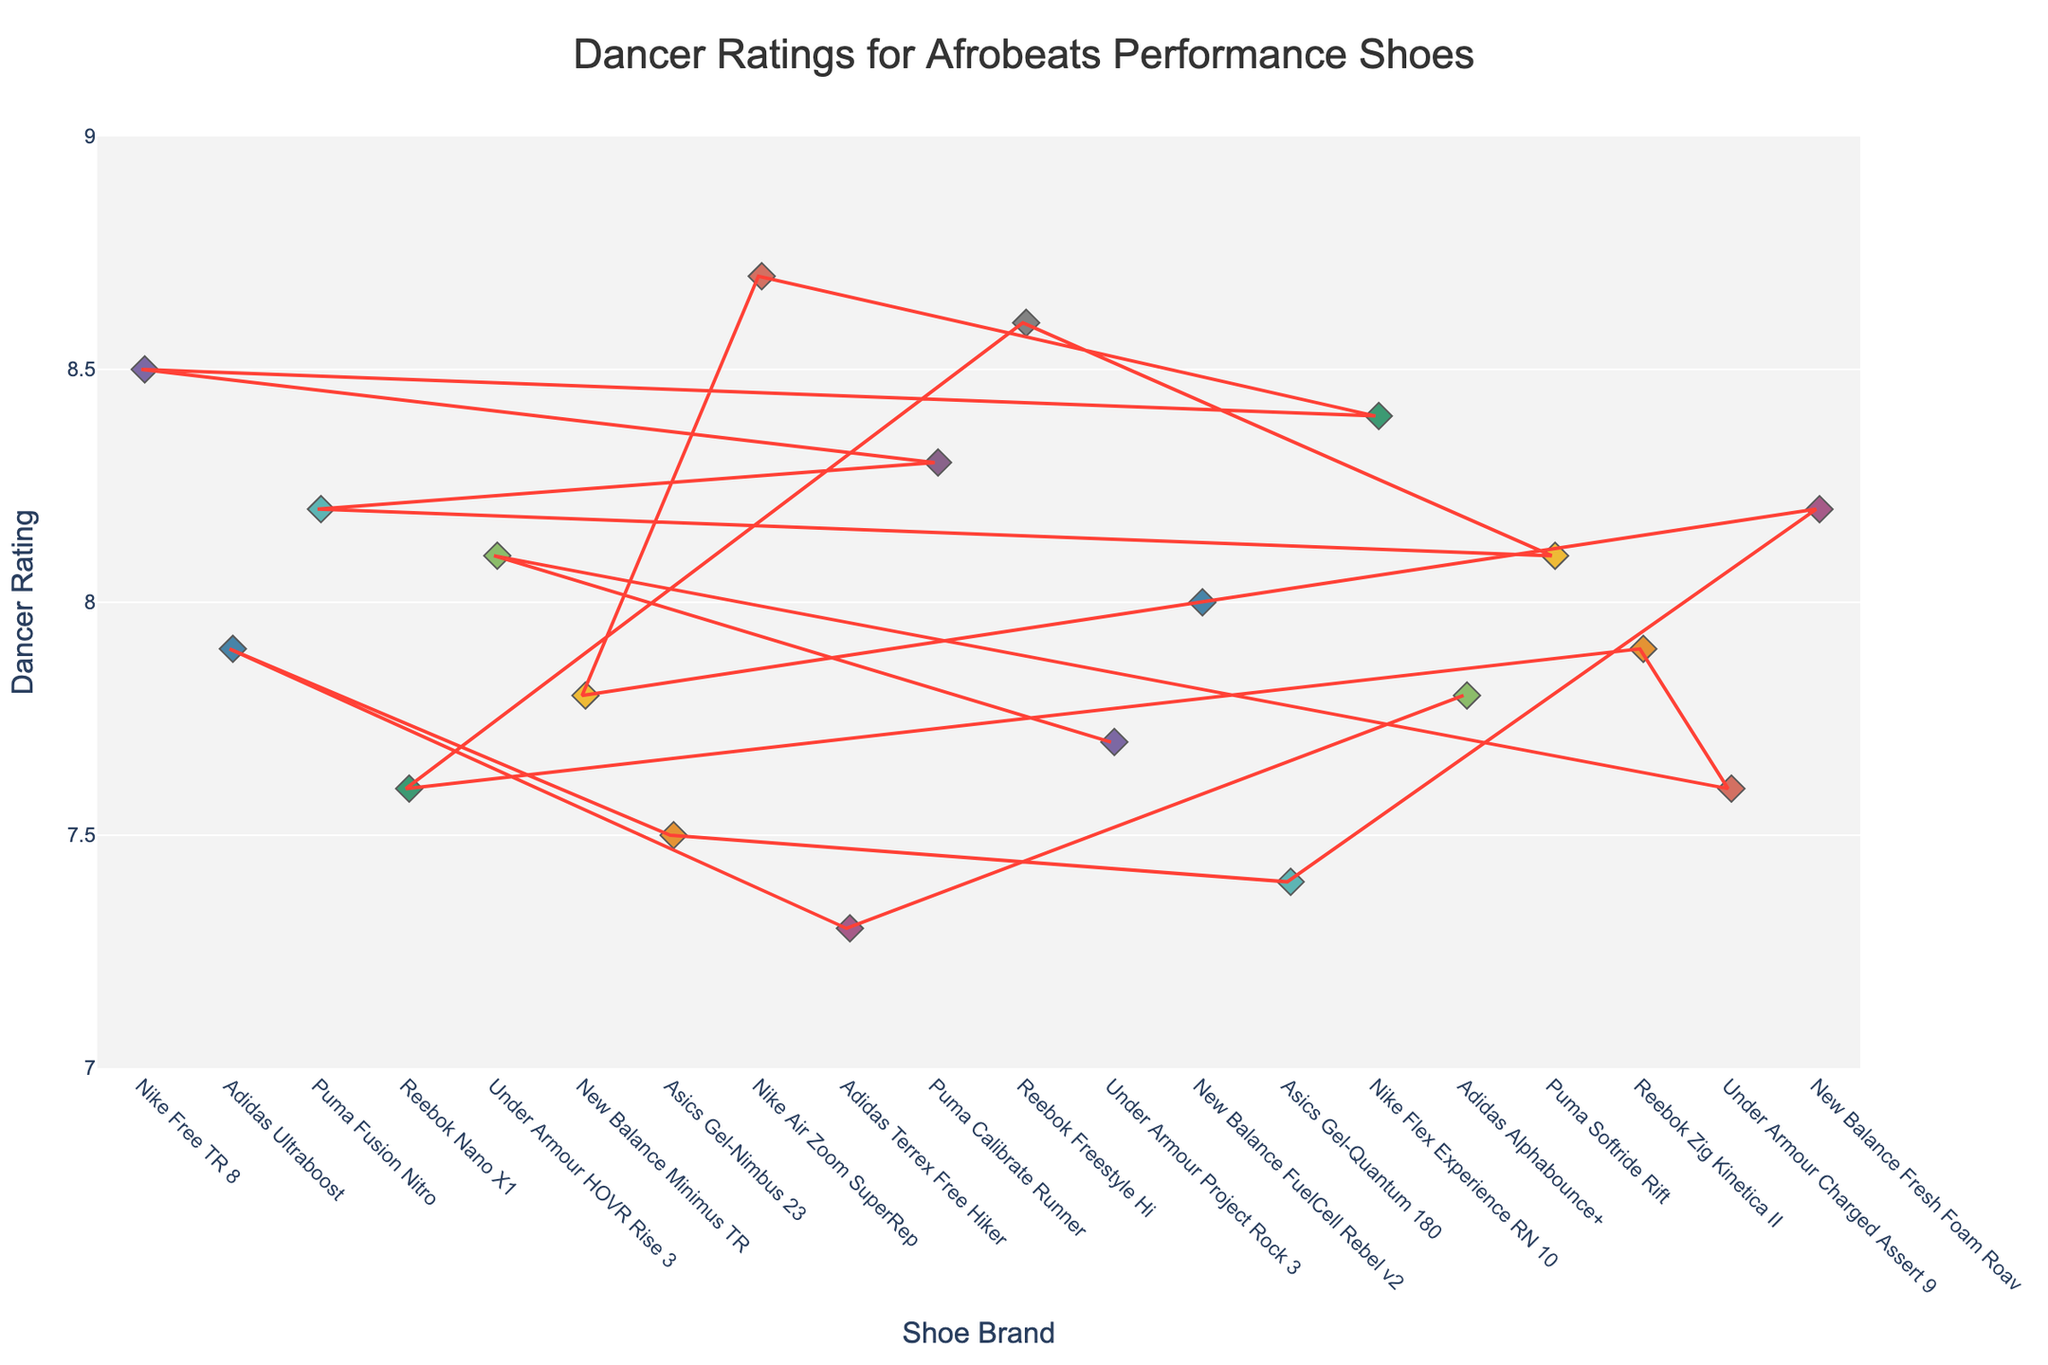What is the highest rating given to a brand? To find the highest rating, look for the topmost point on the plot. The highest rating given is 8.7 for the "Nike Air Zoom SuperRep".
Answer: 8.7 Which brand has the most consistent ratings? Consistent ratings would appear as closely clustered points. The "New Balance Minimus TR" has ratings mostly around 7.8, indicating consistency.
Answer: New Balance Minimus TR How many brands received ratings of 8.0 or higher? Count all distinct brands that have points at or above the 8.0 mark on the y-axis. Brands with ratings of 8.0 or higher include Nike, Puma, Reebok, New Balance, and Asics, totaling to 5 brands.
Answer: 5 What’s the average rating for all brands combined? Sum all the ratings and divide by the number of brands. The total rating sum is 154, and there are 20 brands. Hence, the average rating is 154 / 20 = 7.7.
Answer: 7.7 Which brand has the lowest rating and what is it? To find the lowest rating, look for the bottommost point on the plot. The lowest rating is 7.3 for the "Adidas Terrex Free Hiker".
Answer: Adidas Terrex Free Hiker, 7.3 How does the rating of "Puma Fusion Nitro" compare to "Reebok Nano X1"? Find the points for both brands and compare their y-values. "Puma Fusion Nitro" is rated at 8.2, while "Reebok Nano X1" is rated at 7.6, making Puma's rating higher.
Answer: Puma Fusion Nitro is higher Which brand has a rating closest to the average rating? The average rating is 7.7. Look for the brand with a rating nearest to this value. The "Under Armour Project Rock 3" has a rating of 7.7, which matches the average.
Answer: Under Armour Project Rock 3 What is the range of ratings for the brands? The range can be found by subtracting the lowest rating from the highest rating. The highest rating is 8.7 and the lowest is 7.3 giving a range of 8.7 - 7.3 = 1.4.
Answer: 1.4 